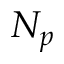Convert formula to latex. <formula><loc_0><loc_0><loc_500><loc_500>N _ { p }</formula> 